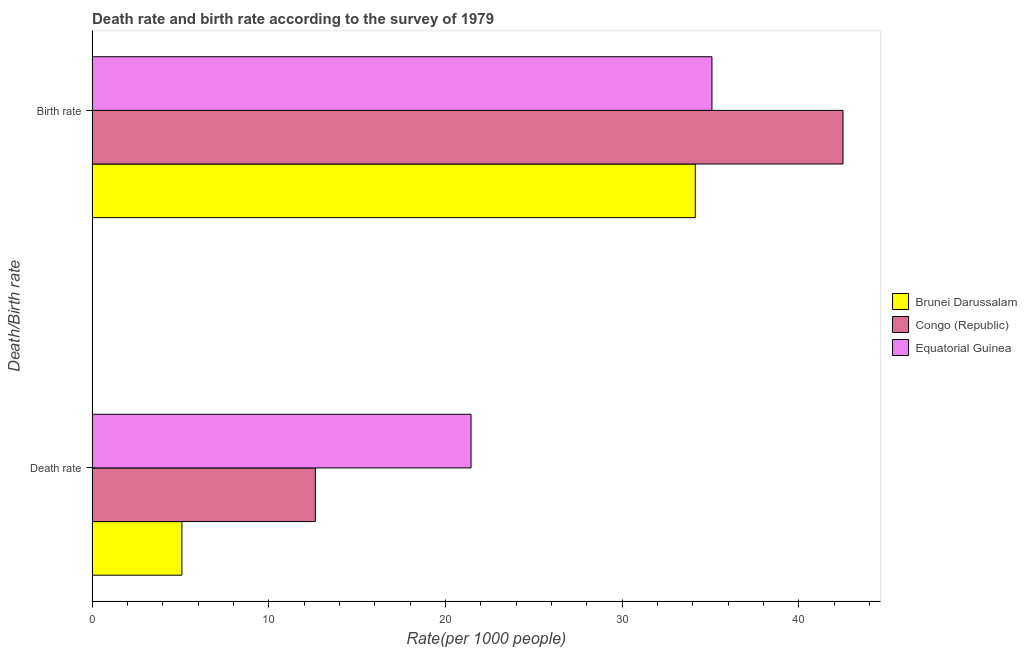How many different coloured bars are there?
Your response must be concise. 3. How many groups of bars are there?
Keep it short and to the point. 2. Are the number of bars per tick equal to the number of legend labels?
Provide a succinct answer. Yes. Are the number of bars on each tick of the Y-axis equal?
Your answer should be very brief. Yes. How many bars are there on the 1st tick from the bottom?
Provide a short and direct response. 3. What is the label of the 1st group of bars from the top?
Your response must be concise. Birth rate. What is the birth rate in Equatorial Guinea?
Provide a succinct answer. 35.08. Across all countries, what is the maximum death rate?
Ensure brevity in your answer.  21.45. Across all countries, what is the minimum birth rate?
Make the answer very short. 34.14. In which country was the birth rate maximum?
Offer a terse response. Congo (Republic). In which country was the birth rate minimum?
Offer a terse response. Brunei Darussalam. What is the total death rate in the graph?
Provide a succinct answer. 39.16. What is the difference between the birth rate in Equatorial Guinea and that in Brunei Darussalam?
Make the answer very short. 0.94. What is the difference between the death rate in Congo (Republic) and the birth rate in Brunei Darussalam?
Offer a terse response. -21.5. What is the average birth rate per country?
Provide a succinct answer. 37.24. What is the difference between the birth rate and death rate in Brunei Darussalam?
Give a very brief answer. 29.05. In how many countries, is the birth rate greater than 12 ?
Provide a short and direct response. 3. What is the ratio of the birth rate in Congo (Republic) to that in Brunei Darussalam?
Give a very brief answer. 1.24. Is the death rate in Brunei Darussalam less than that in Congo (Republic)?
Your answer should be compact. Yes. In how many countries, is the birth rate greater than the average birth rate taken over all countries?
Your answer should be compact. 1. What does the 2nd bar from the top in Birth rate represents?
Give a very brief answer. Congo (Republic). What does the 2nd bar from the bottom in Birth rate represents?
Make the answer very short. Congo (Republic). Are all the bars in the graph horizontal?
Offer a terse response. Yes. What is the difference between two consecutive major ticks on the X-axis?
Your response must be concise. 10. Does the graph contain any zero values?
Offer a very short reply. No. Does the graph contain grids?
Your answer should be compact. No. How many legend labels are there?
Keep it short and to the point. 3. What is the title of the graph?
Your answer should be compact. Death rate and birth rate according to the survey of 1979. Does "Costa Rica" appear as one of the legend labels in the graph?
Your answer should be very brief. No. What is the label or title of the X-axis?
Provide a short and direct response. Rate(per 1000 people). What is the label or title of the Y-axis?
Offer a very short reply. Death/Birth rate. What is the Rate(per 1000 people) in Brunei Darussalam in Death rate?
Your response must be concise. 5.08. What is the Rate(per 1000 people) in Congo (Republic) in Death rate?
Ensure brevity in your answer.  12.63. What is the Rate(per 1000 people) of Equatorial Guinea in Death rate?
Make the answer very short. 21.45. What is the Rate(per 1000 people) in Brunei Darussalam in Birth rate?
Your answer should be compact. 34.14. What is the Rate(per 1000 people) in Congo (Republic) in Birth rate?
Keep it short and to the point. 42.5. What is the Rate(per 1000 people) of Equatorial Guinea in Birth rate?
Ensure brevity in your answer.  35.08. Across all Death/Birth rate, what is the maximum Rate(per 1000 people) in Brunei Darussalam?
Give a very brief answer. 34.14. Across all Death/Birth rate, what is the maximum Rate(per 1000 people) in Congo (Republic)?
Provide a short and direct response. 42.5. Across all Death/Birth rate, what is the maximum Rate(per 1000 people) of Equatorial Guinea?
Provide a short and direct response. 35.08. Across all Death/Birth rate, what is the minimum Rate(per 1000 people) of Brunei Darussalam?
Your response must be concise. 5.08. Across all Death/Birth rate, what is the minimum Rate(per 1000 people) of Congo (Republic)?
Provide a short and direct response. 12.63. Across all Death/Birth rate, what is the minimum Rate(per 1000 people) in Equatorial Guinea?
Keep it short and to the point. 21.45. What is the total Rate(per 1000 people) in Brunei Darussalam in the graph?
Your answer should be compact. 39.22. What is the total Rate(per 1000 people) in Congo (Republic) in the graph?
Provide a short and direct response. 55.13. What is the total Rate(per 1000 people) of Equatorial Guinea in the graph?
Your answer should be compact. 56.53. What is the difference between the Rate(per 1000 people) in Brunei Darussalam in Death rate and that in Birth rate?
Give a very brief answer. -29.05. What is the difference between the Rate(per 1000 people) of Congo (Republic) in Death rate and that in Birth rate?
Your answer should be very brief. -29.86. What is the difference between the Rate(per 1000 people) of Equatorial Guinea in Death rate and that in Birth rate?
Give a very brief answer. -13.63. What is the difference between the Rate(per 1000 people) in Brunei Darussalam in Death rate and the Rate(per 1000 people) in Congo (Republic) in Birth rate?
Your answer should be compact. -37.41. What is the difference between the Rate(per 1000 people) of Brunei Darussalam in Death rate and the Rate(per 1000 people) of Equatorial Guinea in Birth rate?
Your response must be concise. -30. What is the difference between the Rate(per 1000 people) in Congo (Republic) in Death rate and the Rate(per 1000 people) in Equatorial Guinea in Birth rate?
Offer a terse response. -22.45. What is the average Rate(per 1000 people) in Brunei Darussalam per Death/Birth rate?
Give a very brief answer. 19.61. What is the average Rate(per 1000 people) in Congo (Republic) per Death/Birth rate?
Keep it short and to the point. 27.57. What is the average Rate(per 1000 people) in Equatorial Guinea per Death/Birth rate?
Offer a terse response. 28.26. What is the difference between the Rate(per 1000 people) in Brunei Darussalam and Rate(per 1000 people) in Congo (Republic) in Death rate?
Your response must be concise. -7.55. What is the difference between the Rate(per 1000 people) of Brunei Darussalam and Rate(per 1000 people) of Equatorial Guinea in Death rate?
Keep it short and to the point. -16.36. What is the difference between the Rate(per 1000 people) of Congo (Republic) and Rate(per 1000 people) of Equatorial Guinea in Death rate?
Make the answer very short. -8.81. What is the difference between the Rate(per 1000 people) in Brunei Darussalam and Rate(per 1000 people) in Congo (Republic) in Birth rate?
Give a very brief answer. -8.36. What is the difference between the Rate(per 1000 people) in Brunei Darussalam and Rate(per 1000 people) in Equatorial Guinea in Birth rate?
Offer a very short reply. -0.94. What is the difference between the Rate(per 1000 people) of Congo (Republic) and Rate(per 1000 people) of Equatorial Guinea in Birth rate?
Your response must be concise. 7.42. What is the ratio of the Rate(per 1000 people) of Brunei Darussalam in Death rate to that in Birth rate?
Your answer should be very brief. 0.15. What is the ratio of the Rate(per 1000 people) in Congo (Republic) in Death rate to that in Birth rate?
Your answer should be compact. 0.3. What is the ratio of the Rate(per 1000 people) of Equatorial Guinea in Death rate to that in Birth rate?
Offer a terse response. 0.61. What is the difference between the highest and the second highest Rate(per 1000 people) of Brunei Darussalam?
Offer a very short reply. 29.05. What is the difference between the highest and the second highest Rate(per 1000 people) of Congo (Republic)?
Offer a terse response. 29.86. What is the difference between the highest and the second highest Rate(per 1000 people) of Equatorial Guinea?
Offer a terse response. 13.63. What is the difference between the highest and the lowest Rate(per 1000 people) of Brunei Darussalam?
Provide a short and direct response. 29.05. What is the difference between the highest and the lowest Rate(per 1000 people) in Congo (Republic)?
Give a very brief answer. 29.86. What is the difference between the highest and the lowest Rate(per 1000 people) in Equatorial Guinea?
Offer a very short reply. 13.63. 